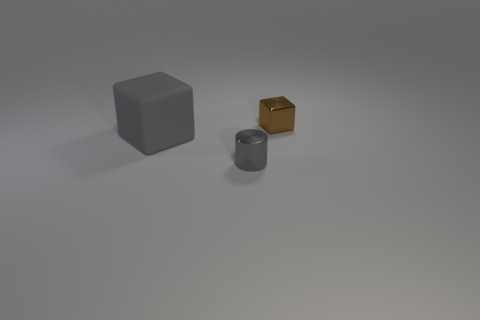Subtract all gray cubes. How many cubes are left? 1 Add 2 brown metal cubes. How many objects exist? 5 Subtract all blocks. How many objects are left? 1 Subtract all tiny brown metal things. Subtract all gray blocks. How many objects are left? 1 Add 3 gray things. How many gray things are left? 5 Add 1 brown shiny cubes. How many brown shiny cubes exist? 2 Subtract 0 purple blocks. How many objects are left? 3 Subtract all gray blocks. Subtract all gray cylinders. How many blocks are left? 1 